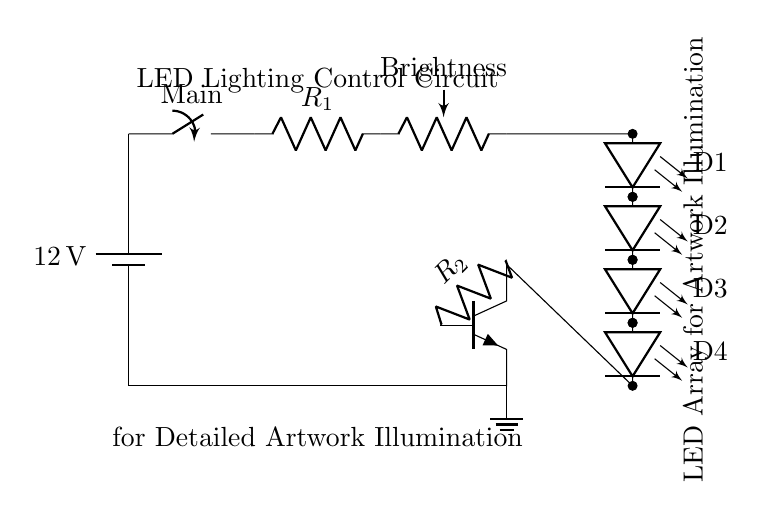What is the voltage supplied by the battery? The voltage supplied by the battery is twelve volts, as indicated by the label next to the battery symbol in the diagram.
Answer: twelve volts What is the role of resistor R1? Resistor R1 is used for current limiting, preventing excessive current from flowing through the LED array, which could damage the LEDs.
Answer: current limiting How many LEDs are in the circuit? There are four LEDs in the circuit, as shown in the diagram where D1, D2, D3, and D4 are labeled next to four LED symbols.
Answer: four What component is used to control brightness? The component used to control brightness is a potentiometer, labeled as "Brightness" in the diagram.
Answer: potentiometer What type of transistor is used in this circuit? The type of transistor used is an NPN transistor, identified by the npn label and its graphical representation in the diagram.
Answer: NPN Why is there a resistor connected to the base of the transistor? The resistor R2 connected to the base of the transistor is used to limit the base current for proper operation of the transistor; this ensures that the transistor is driven into saturation when needed.
Answer: to limit base current Which component connects the circuit to ground? The ground connection is made through the ground symbol, which connects at the bottom of the circuit, completing the circuit path for returning current.
Answer: ground symbol 